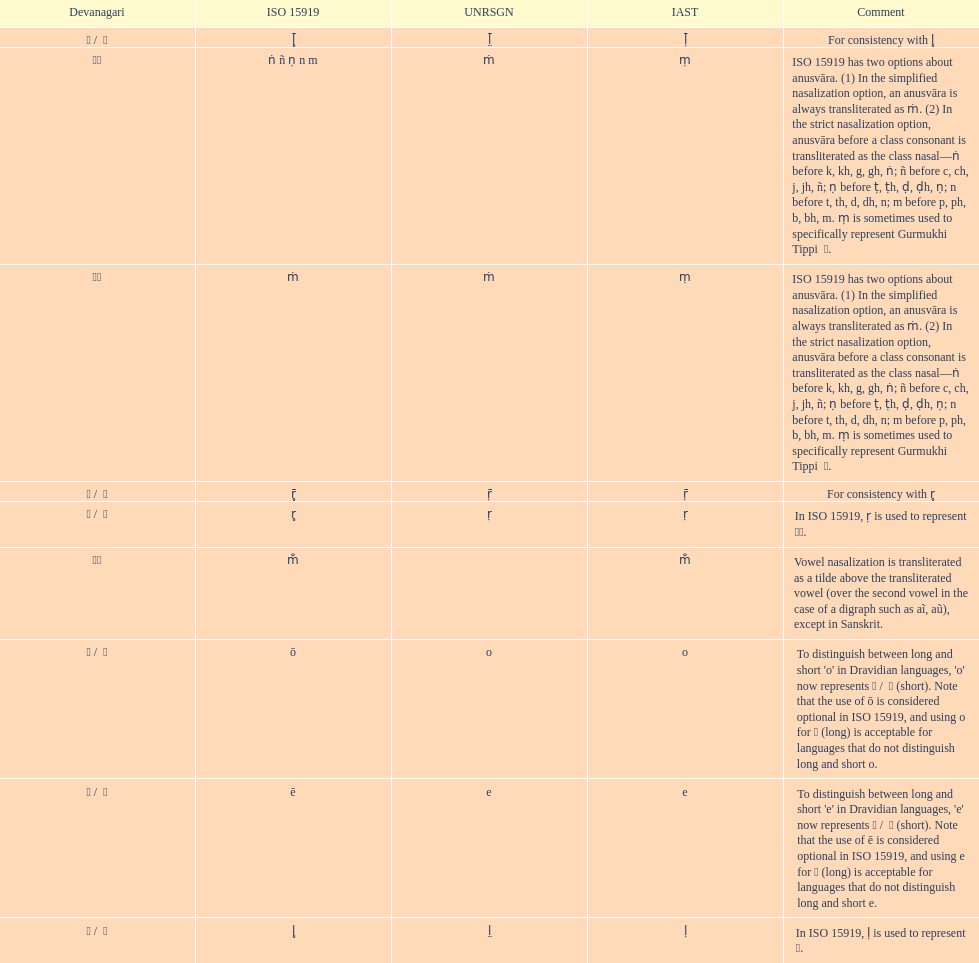What is the total number of translations? 8. 